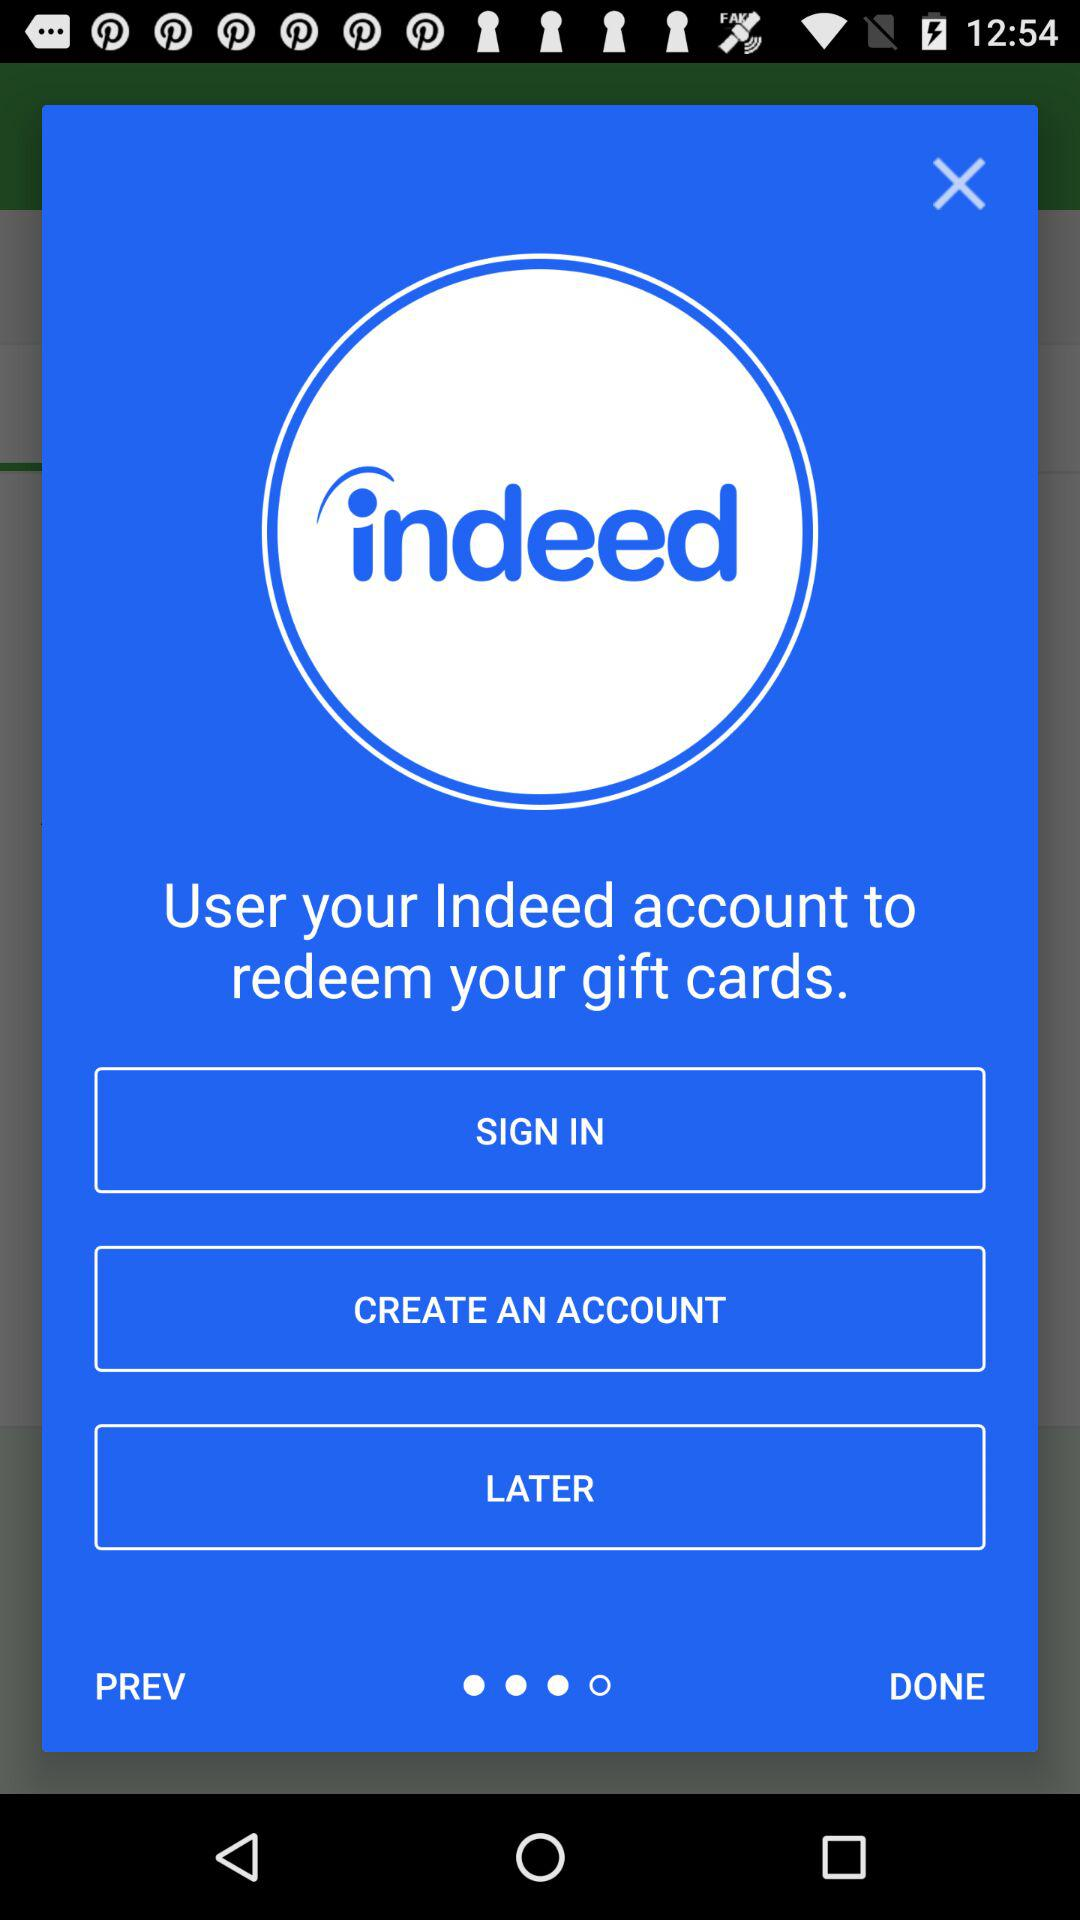What is the application name? The application name is "indeed". 